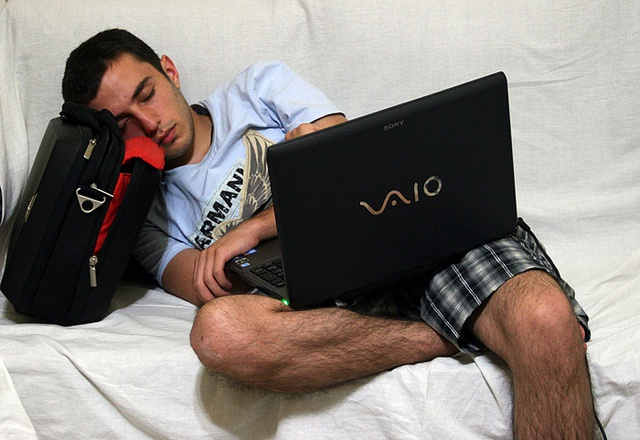Describe the objects in this image and their specific colors. I can see couch in lightgray, darkgray, and gray tones, people in lightgray, black, brown, and lavender tones, laptop in lightgray, black, gray, and ivory tones, and backpack in lightgray, black, maroon, and brown tones in this image. 